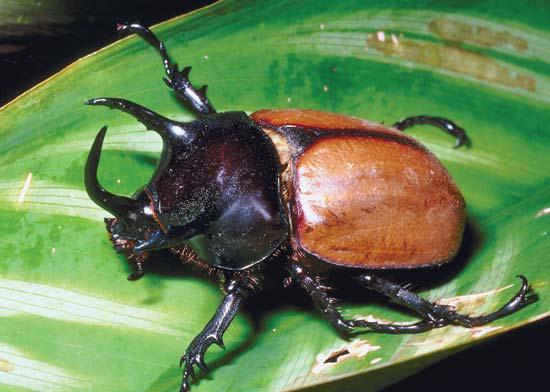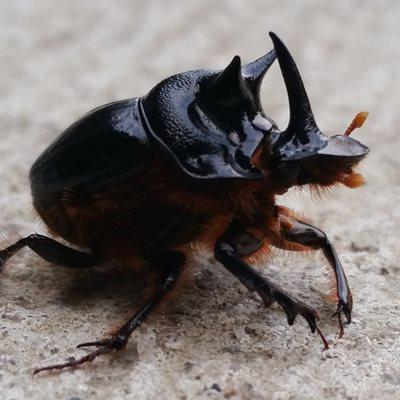The first image is the image on the left, the second image is the image on the right. For the images displayed, is the sentence "The beetle on the left is near green grass." factually correct? Answer yes or no. No. The first image is the image on the left, the second image is the image on the right. Evaluate the accuracy of this statement regarding the images: "One image shows the underside of a beetle instead of the top side.". Is it true? Answer yes or no. No. 